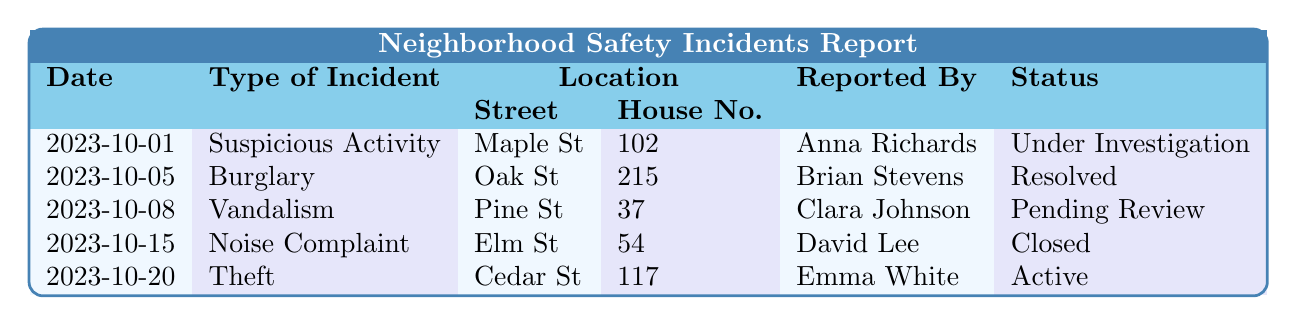What type of incident was reported on 2023-10-05? The table indicates that on 2023-10-05, the type of incident reported was "Burglary."
Answer: Burglary How many incidents are currently under investigation? Referring to the table, there is one incident under investigation, which is marked as "Under Investigation."
Answer: 1 Which incident was reported by David Lee? According to the table, David Lee reported a "Noise Complaint" on 2023-10-15.
Answer: Noise Complaint What is the status of the vandalism incident? The vandalism incident, reported on 2023-10-08, has the status "Pending Review."
Answer: Pending Review Which street had an incident involving theft on October 20, 2023? The incident involving theft on October 20, 2023, occurred on "Cedar St."
Answer: Cedar St How many different types of incidents are documented in this report? The report includes five distinct types of incidents: Suspicious Activity, Burglary, Vandalism, Noise Complaint, and Theft.
Answer: 5 Did any incidents report being resolved? Yes, the burglary incident reported on 2023-10-05 is marked as "Resolved."
Answer: Yes Identify the person who reported the suspicious activity incident. The suspicious activity incident was reported by Anna Richards on October 1, 2023.
Answer: Anna Richards What is the most recent incident reported, and what is its type? The most recent incident in the table is from October 20, 2023, and it is a Theft incident.
Answer: Theft How many incidents remain active or under investigation? There are two incidents: one "Under Investigation" and one "Active," totaling two that are not resolved.
Answer: 2 What is the status of the incident reported by Clara Johnson? Clara Johnson's incident reported on October 8, 2023, has the status "Pending Review."
Answer: Pending Review What type of incident happened first chronologically? The first incident reported chronologically is a "Suspicious Activity" on October 1, 2023.
Answer: Suspicious Activity 